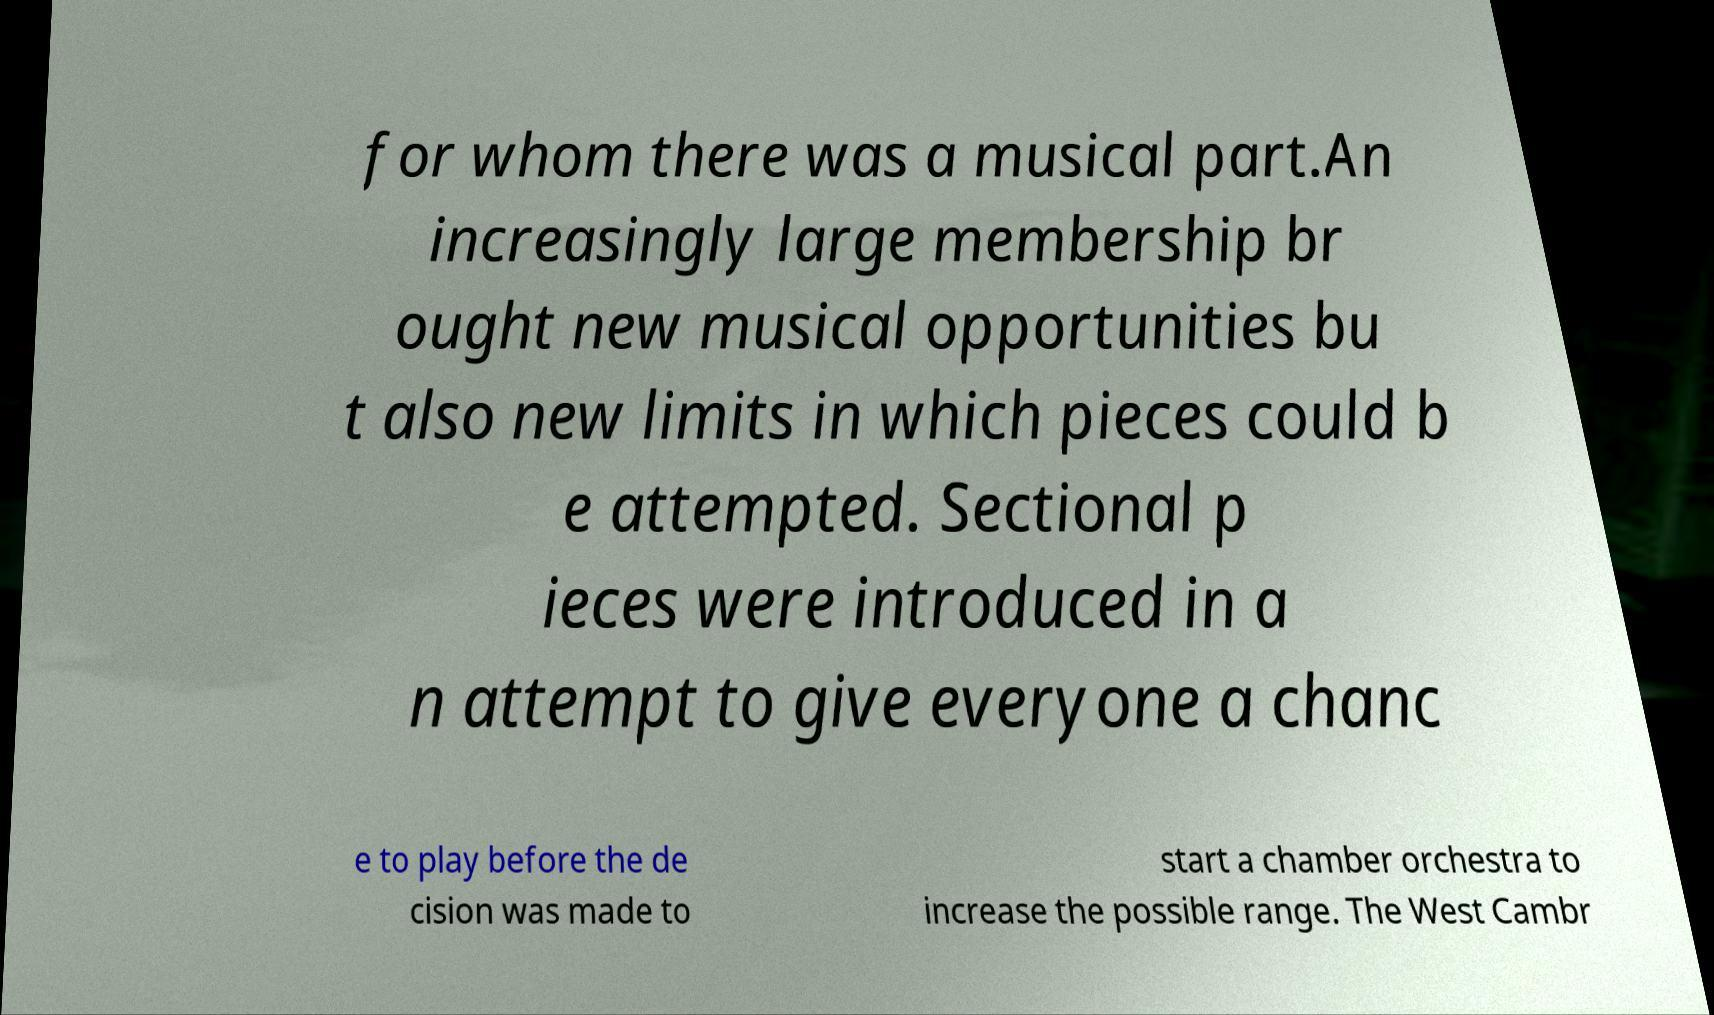Can you accurately transcribe the text from the provided image for me? for whom there was a musical part.An increasingly large membership br ought new musical opportunities bu t also new limits in which pieces could b e attempted. Sectional p ieces were introduced in a n attempt to give everyone a chanc e to play before the de cision was made to start a chamber orchestra to increase the possible range. The West Cambr 